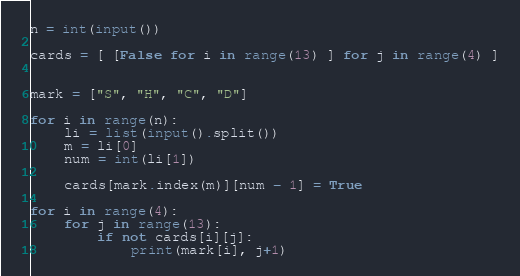<code> <loc_0><loc_0><loc_500><loc_500><_Python_>n = int(input())

cards = [ [False for i in range(13) ] for j in range(4) ]


mark = ["S", "H", "C", "D"]

for i in range(n):
	li = list(input().split())
	m = li[0]
	num = int(li[1])

	cards[mark.index(m)][num - 1] = True
	
for i in range(4):
	for j in range(13):
		if not cards[i][j]:
			print(mark[i], j+1)


</code> 